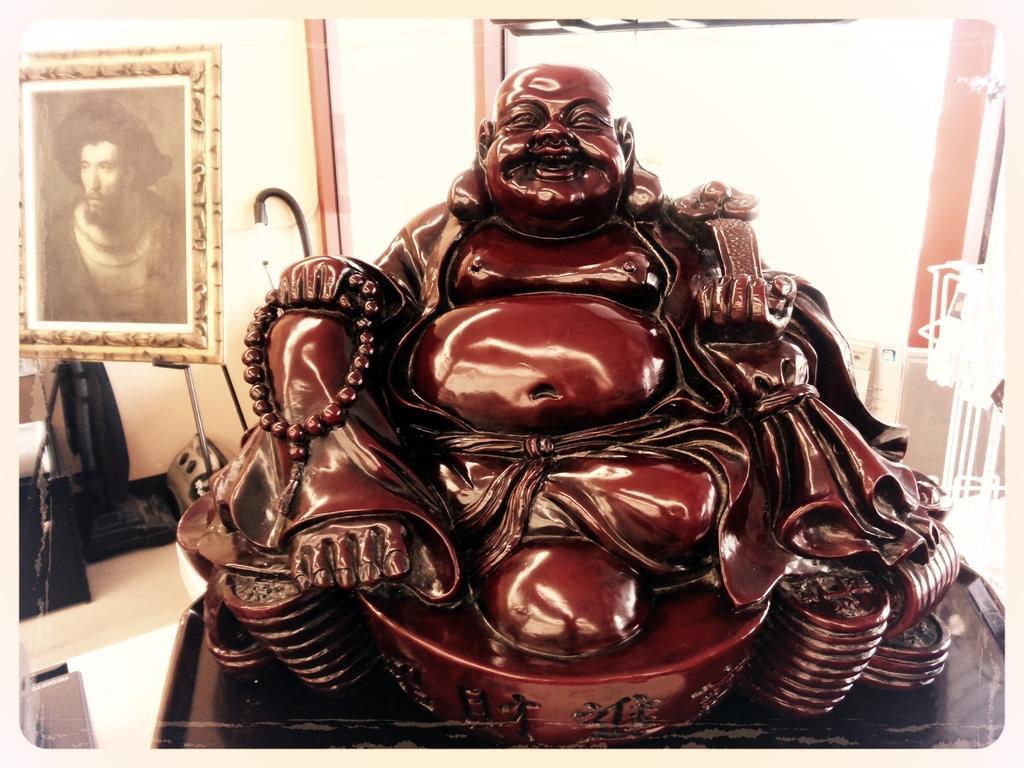How would you summarize this image in a sentence or two? In this image, I can see the sculpture of a laughing Buddha. This looks like a frame, which is attached to the wall. I think this is a machine, which is placed on the floor. 